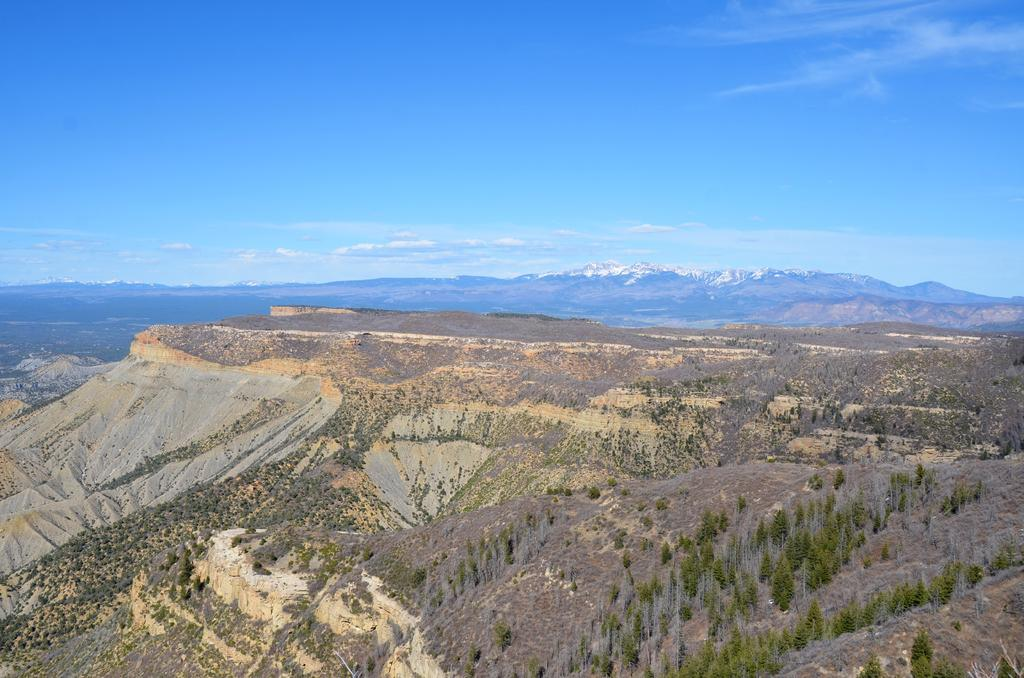What type of vegetation is present in the image? There are trees in the image. What can be seen in the background of the image? There are clouds and the sky visible in the background of the image. What type of crown is worn by the cow in the image? There is no cow or crown present in the image. 